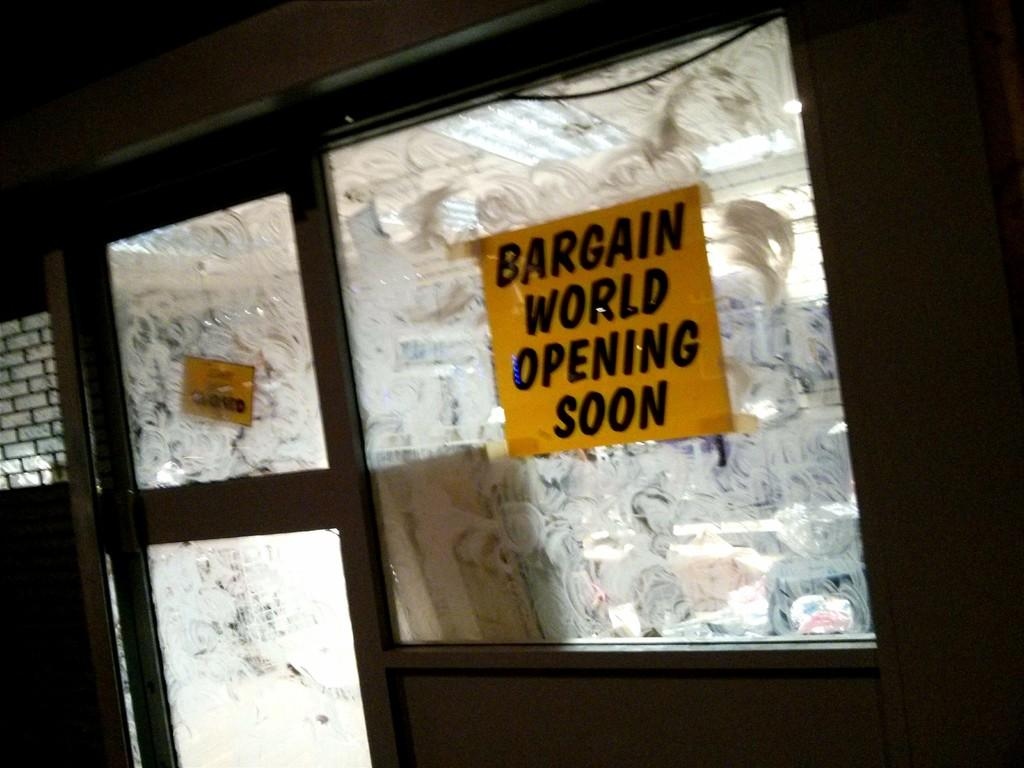What is on the glass window in the image? There is a paper with text on it in the image. Where is the paper located in relation to the door and wall? The paper is on a glass window, which is part of the door, and there is a wall visible in the image. What is the belief of the heat in the image? There is no mention of heat in the image, so it is not possible to determine any beliefs about it. 